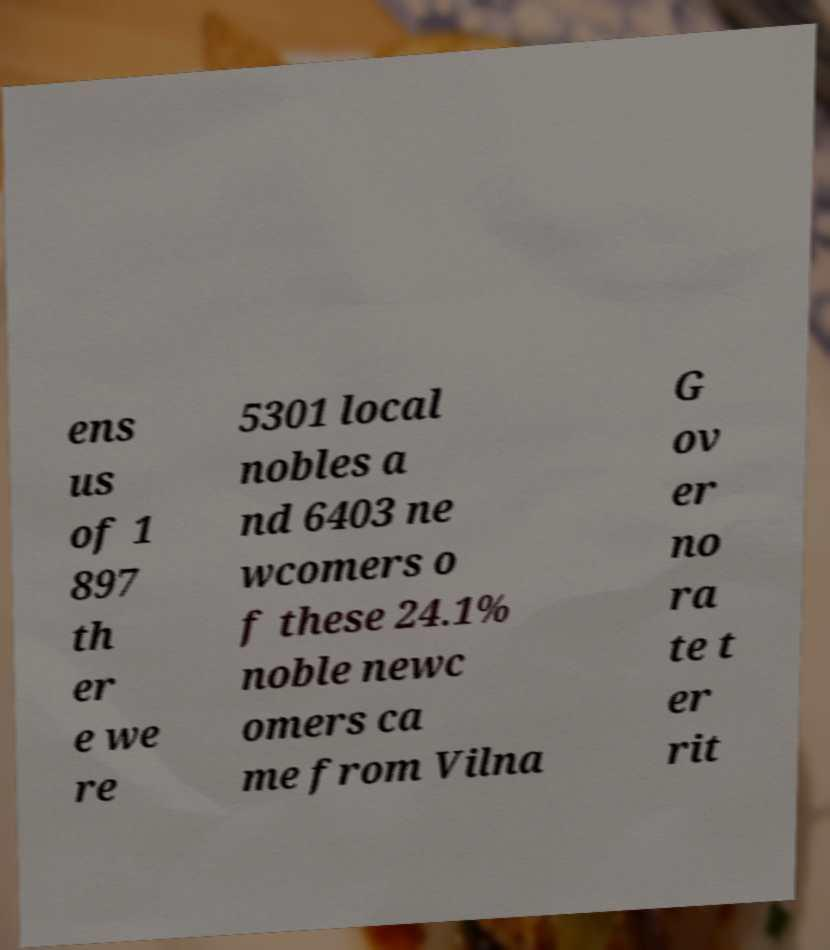Could you assist in decoding the text presented in this image and type it out clearly? ens us of 1 897 th er e we re 5301 local nobles a nd 6403 ne wcomers o f these 24.1% noble newc omers ca me from Vilna G ov er no ra te t er rit 